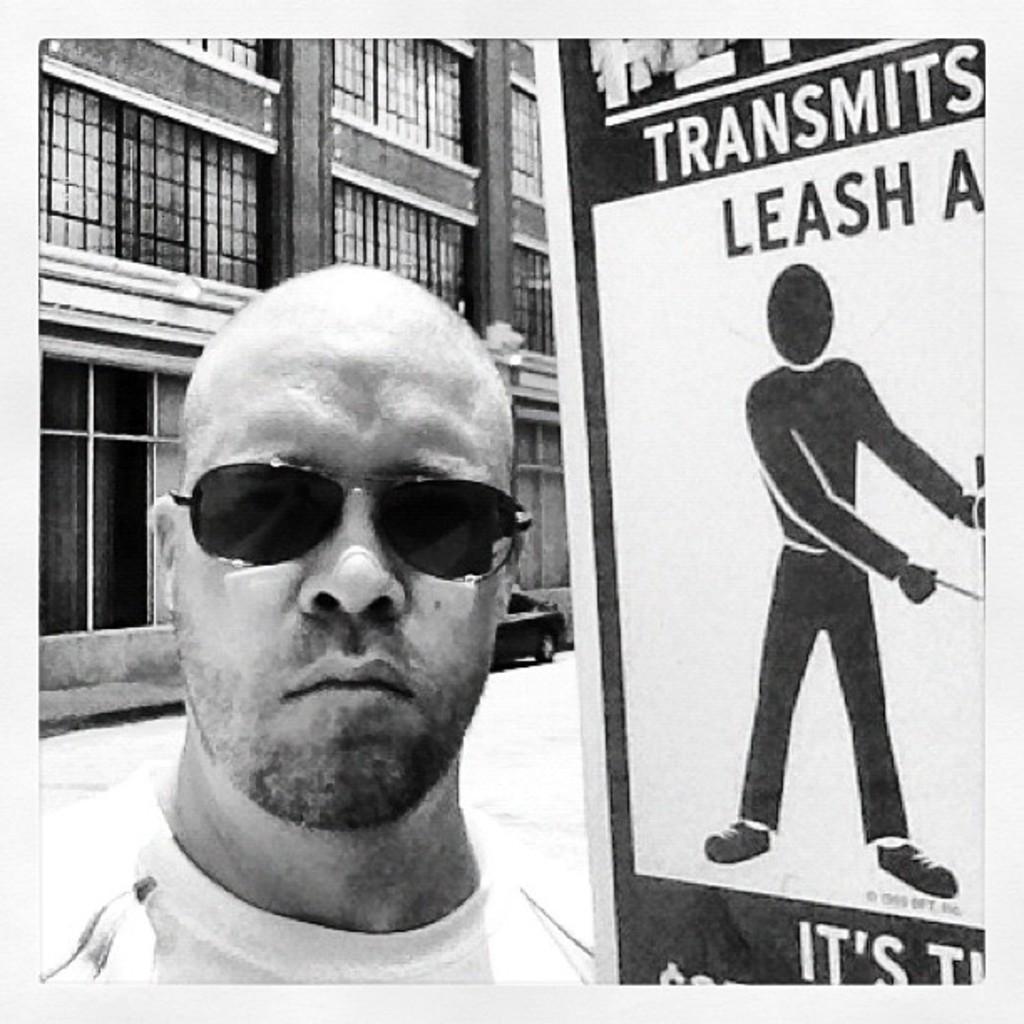Can you describe this image briefly? In this picture there is a man wearing black sunglasses is looking into the camera. Beside there is a white poster. In the background we can see a building with glass window. 